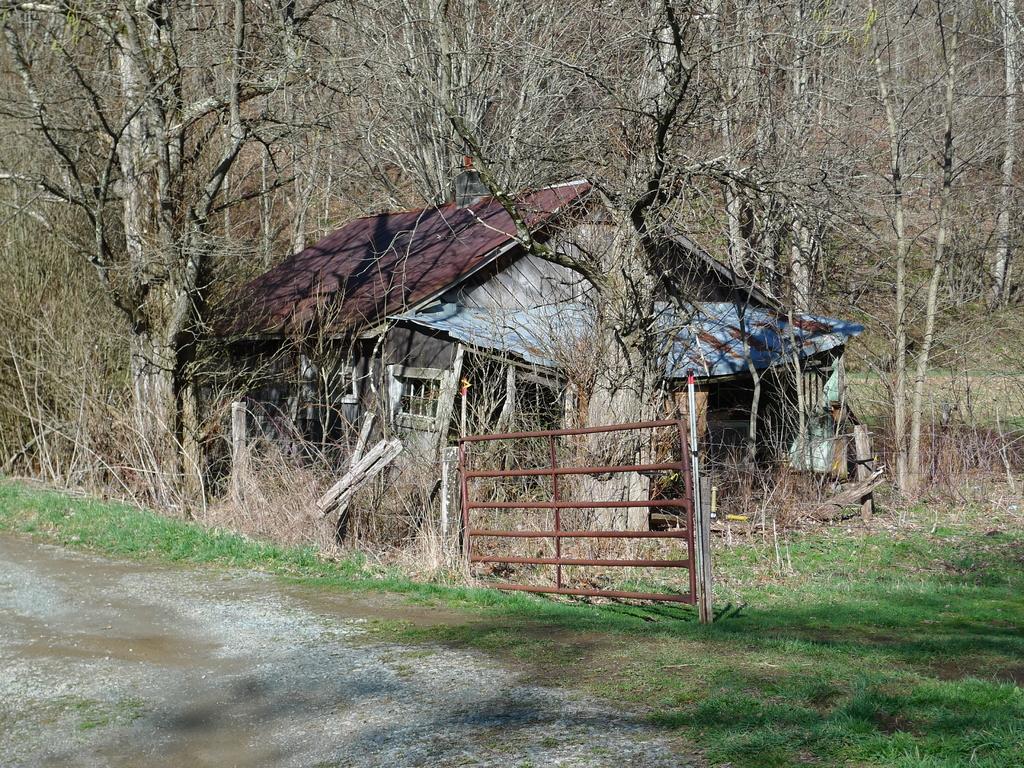In one or two sentences, can you explain what this image depicts? In the center of the image we can see a gate, a building with a roof. In the background, we can see a group of trees. 